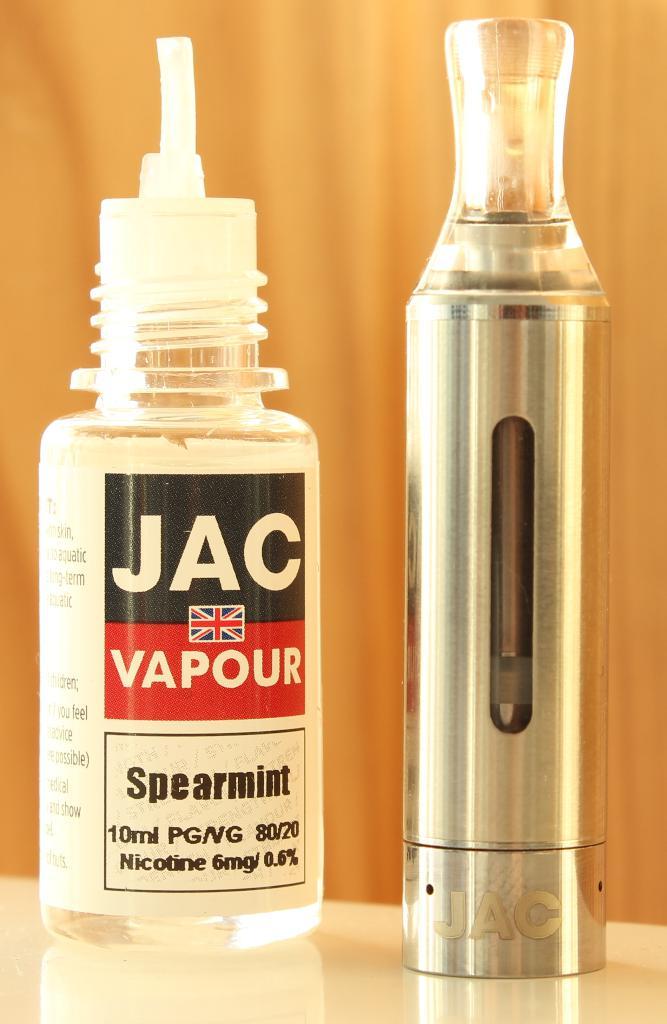What is the flavor of the liquid nicotine?
Your answer should be compact. Spearmint. What is the left liquid?
Provide a succinct answer. Vapour. 